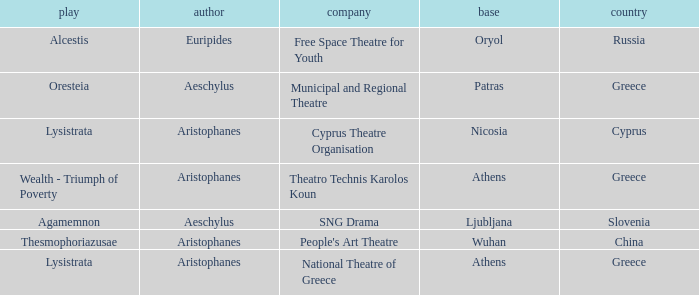In which nation is ljubljana the main city? Slovenia. 